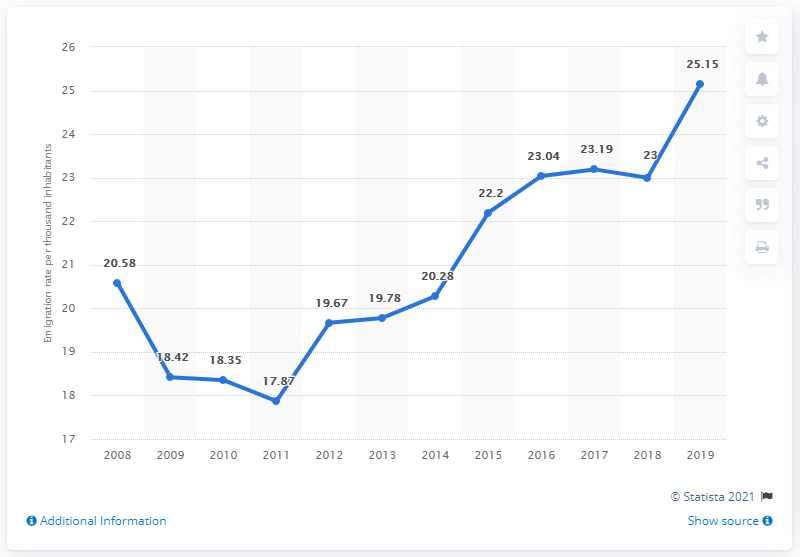Point out several critical features in this image. In 2019, the emigration rate in Luxembourg was 25.15 per thousand inhabitants. In 2011, there was a lower rate of emigration in Luxembourg compared to other years. In the year 2018, the emigration rate was 2.15, while in 2019, the emigration rate increased to 2.16. 